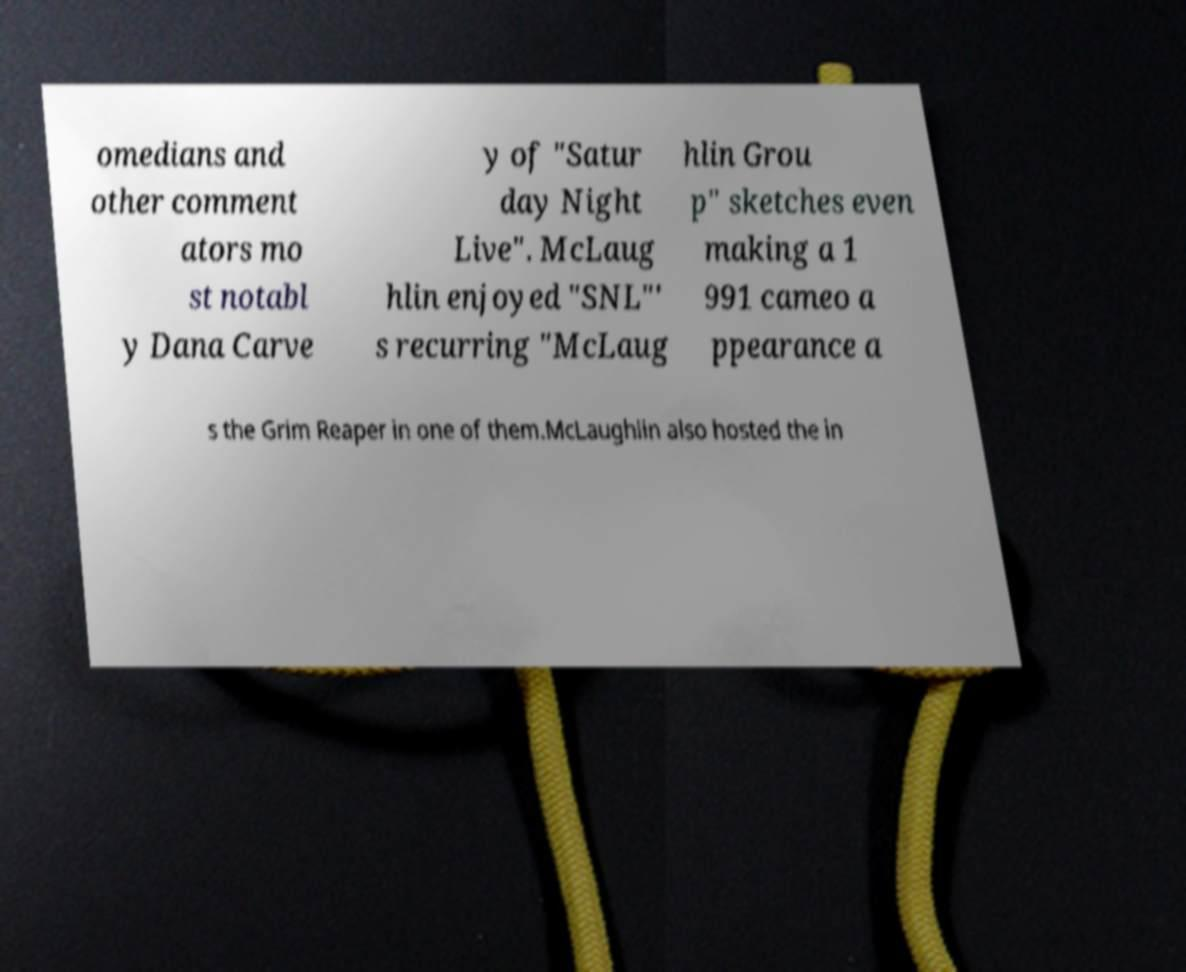For documentation purposes, I need the text within this image transcribed. Could you provide that? omedians and other comment ators mo st notabl y Dana Carve y of "Satur day Night Live". McLaug hlin enjoyed "SNL"' s recurring "McLaug hlin Grou p" sketches even making a 1 991 cameo a ppearance a s the Grim Reaper in one of them.McLaughlin also hosted the in 